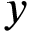<formula> <loc_0><loc_0><loc_500><loc_500>y</formula> 